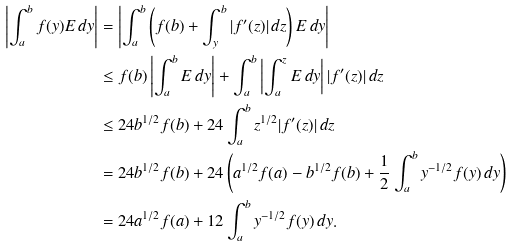<formula> <loc_0><loc_0><loc_500><loc_500>\left | \int _ { a } ^ { b } f ( y ) E \, d y \right | & = \left | \int _ { a } ^ { b } \left ( f ( b ) + \int _ { y } ^ { b } | f ^ { \prime } ( z ) | \, d z \right ) E \, d y \right | \\ & \leq f ( b ) \left | \int _ { a } ^ { b } E \, d y \right | + \int _ { a } ^ { b } \left | \int _ { a } ^ { z } E \, d y \right | | f ^ { \prime } ( z ) | \, d z \\ & \leq 2 4 b ^ { 1 / 2 } f ( b ) + 2 4 \int _ { a } ^ { b } z ^ { 1 / 2 } | f ^ { \prime } ( z ) | \, d z \\ & = 2 4 b ^ { 1 / 2 } f ( b ) + 2 4 \left ( a ^ { 1 / 2 } f ( a ) - b ^ { 1 / 2 } f ( b ) + \frac { 1 } { 2 } \int _ { a } ^ { b } y ^ { - 1 / 2 } f ( y ) \, d y \right ) \\ & = 2 4 a ^ { 1 / 2 } f ( a ) + 1 2 \int _ { a } ^ { b } y ^ { - 1 / 2 } f ( y ) \, d y .</formula> 